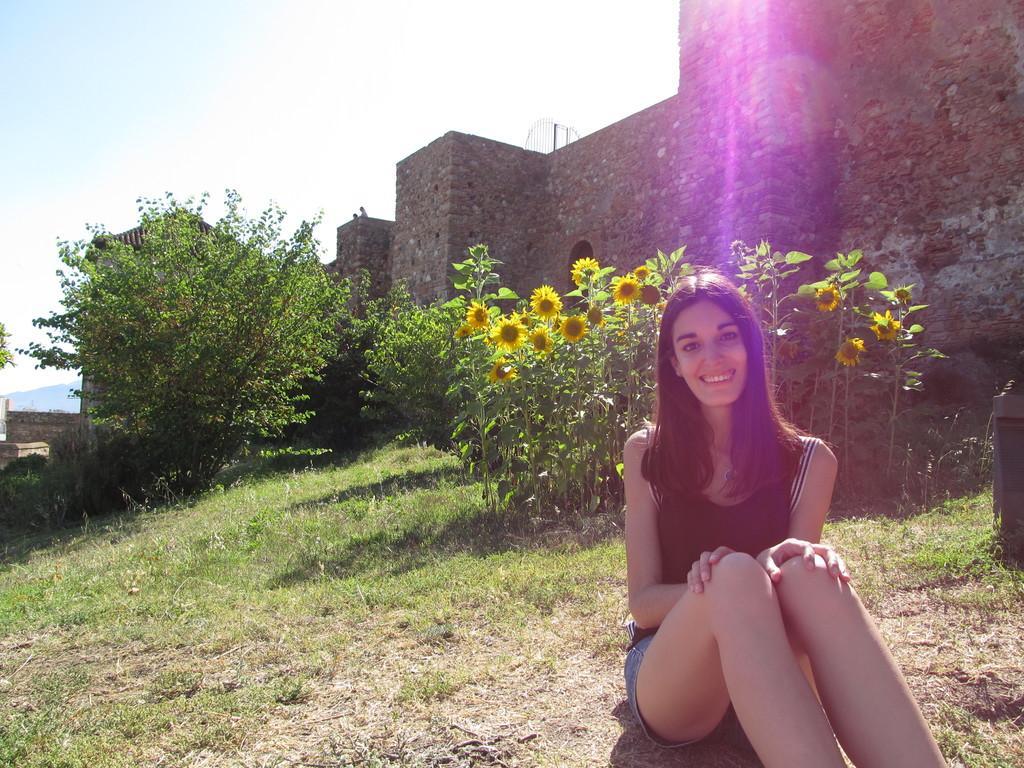Please provide a concise description of this image. In this image in front there is a person sitting on the grass and she is smiling. Behind her there are plants, trees. In the background of the image there are buildings and sky. 